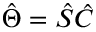Convert formula to latex. <formula><loc_0><loc_0><loc_500><loc_500>\hat { \Theta } = \hat { S } \hat { C }</formula> 